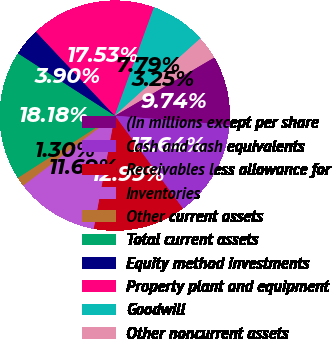Convert chart. <chart><loc_0><loc_0><loc_500><loc_500><pie_chart><fcel>(In millions except per share<fcel>Cash and cash equivalents<fcel>Receivables less allowance for<fcel>Inventories<fcel>Other current assets<fcel>Total current assets<fcel>Equity method investments<fcel>Property plant and equipment<fcel>Goodwill<fcel>Other noncurrent assets<nl><fcel>9.74%<fcel>13.64%<fcel>12.99%<fcel>11.69%<fcel>1.3%<fcel>18.18%<fcel>3.9%<fcel>17.53%<fcel>7.79%<fcel>3.25%<nl></chart> 